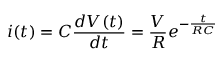<formula> <loc_0><loc_0><loc_500><loc_500>i ( t ) = C \frac { d V ( t ) } { d t } = \frac { V } { R } e ^ { - \frac { t } { R C } }</formula> 